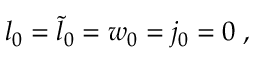Convert formula to latex. <formula><loc_0><loc_0><loc_500><loc_500>l _ { 0 } = { \tilde { l } } _ { 0 } = w _ { 0 } = j _ { 0 } = 0 \, ,</formula> 